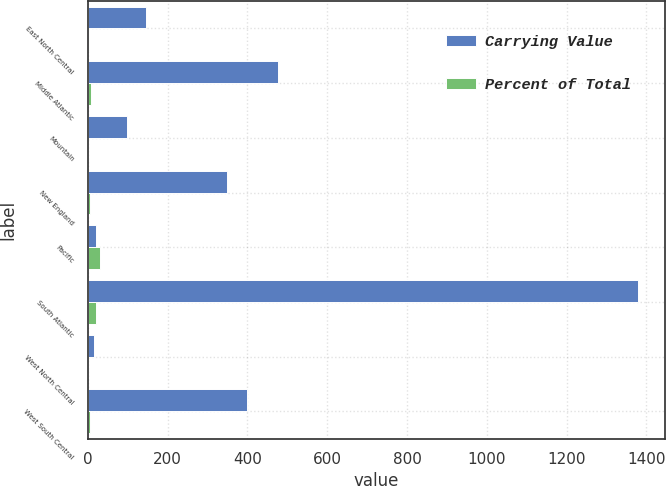Convert chart to OTSL. <chart><loc_0><loc_0><loc_500><loc_500><stacked_bar_chart><ecel><fcel>East North Central<fcel>Middle Atlantic<fcel>Mountain<fcel>New England<fcel>Pacific<fcel>South Atlantic<fcel>West North Central<fcel>West South Central<nl><fcel>Carrying Value<fcel>145<fcel>477<fcel>99<fcel>350<fcel>20.5<fcel>1378<fcel>16<fcel>398<nl><fcel>Percent of Total<fcel>2.2<fcel>7.1<fcel>1.5<fcel>5.2<fcel>29.5<fcel>20.5<fcel>0.2<fcel>5.9<nl></chart> 